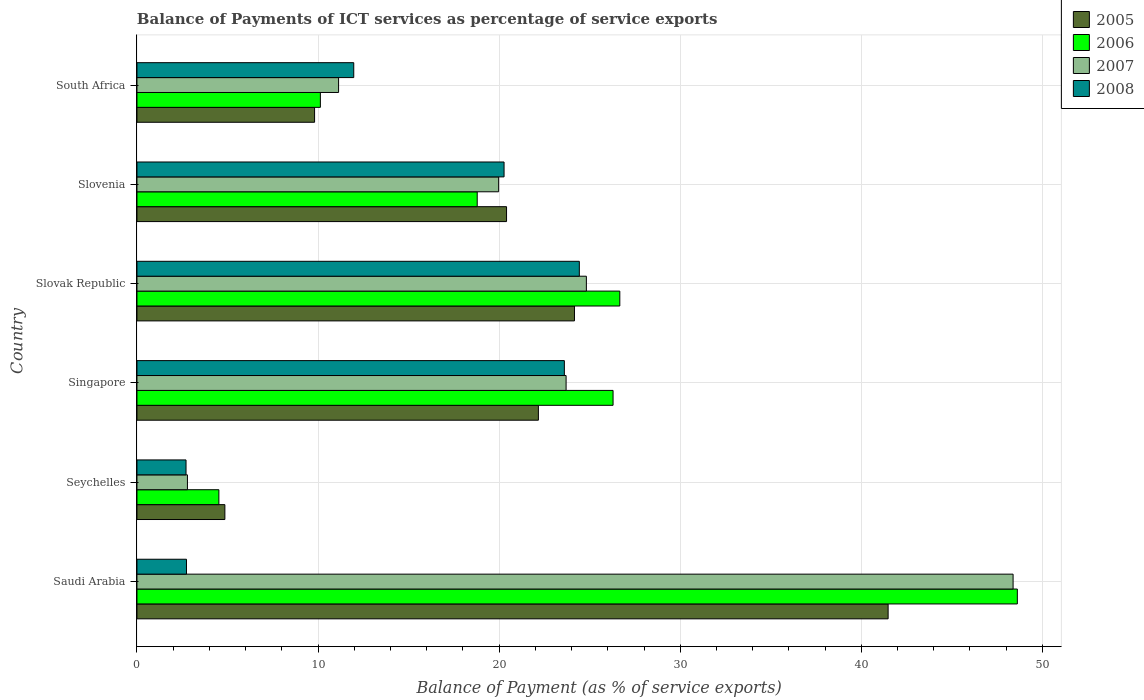How many groups of bars are there?
Give a very brief answer. 6. How many bars are there on the 3rd tick from the top?
Give a very brief answer. 4. What is the label of the 4th group of bars from the top?
Your answer should be very brief. Singapore. What is the balance of payments of ICT services in 2007 in Slovenia?
Give a very brief answer. 19.97. Across all countries, what is the maximum balance of payments of ICT services in 2008?
Keep it short and to the point. 24.43. Across all countries, what is the minimum balance of payments of ICT services in 2006?
Make the answer very short. 4.52. In which country was the balance of payments of ICT services in 2007 maximum?
Keep it short and to the point. Saudi Arabia. In which country was the balance of payments of ICT services in 2008 minimum?
Offer a terse response. Seychelles. What is the total balance of payments of ICT services in 2008 in the graph?
Provide a succinct answer. 85.72. What is the difference between the balance of payments of ICT services in 2005 in Seychelles and that in Slovenia?
Keep it short and to the point. -15.56. What is the difference between the balance of payments of ICT services in 2005 in Seychelles and the balance of payments of ICT services in 2008 in Slovenia?
Offer a very short reply. -15.42. What is the average balance of payments of ICT services in 2006 per country?
Offer a very short reply. 22.5. What is the difference between the balance of payments of ICT services in 2008 and balance of payments of ICT services in 2007 in Saudi Arabia?
Your response must be concise. -45.65. In how many countries, is the balance of payments of ICT services in 2008 greater than 34 %?
Offer a terse response. 0. What is the ratio of the balance of payments of ICT services in 2006 in Singapore to that in South Africa?
Make the answer very short. 2.6. Is the balance of payments of ICT services in 2008 in Slovenia less than that in South Africa?
Provide a succinct answer. No. Is the difference between the balance of payments of ICT services in 2008 in Seychelles and Slovak Republic greater than the difference between the balance of payments of ICT services in 2007 in Seychelles and Slovak Republic?
Offer a very short reply. Yes. What is the difference between the highest and the second highest balance of payments of ICT services in 2007?
Your response must be concise. 23.56. What is the difference between the highest and the lowest balance of payments of ICT services in 2007?
Your response must be concise. 45.59. In how many countries, is the balance of payments of ICT services in 2008 greater than the average balance of payments of ICT services in 2008 taken over all countries?
Offer a terse response. 3. Is the sum of the balance of payments of ICT services in 2005 in Seychelles and Slovak Republic greater than the maximum balance of payments of ICT services in 2006 across all countries?
Your answer should be compact. No. How many bars are there?
Give a very brief answer. 24. Are all the bars in the graph horizontal?
Give a very brief answer. Yes. How many countries are there in the graph?
Give a very brief answer. 6. Does the graph contain any zero values?
Keep it short and to the point. No. Where does the legend appear in the graph?
Make the answer very short. Top right. How many legend labels are there?
Your answer should be compact. 4. How are the legend labels stacked?
Provide a short and direct response. Vertical. What is the title of the graph?
Your response must be concise. Balance of Payments of ICT services as percentage of service exports. What is the label or title of the X-axis?
Provide a short and direct response. Balance of Payment (as % of service exports). What is the Balance of Payment (as % of service exports) in 2005 in Saudi Arabia?
Give a very brief answer. 41.48. What is the Balance of Payment (as % of service exports) of 2006 in Saudi Arabia?
Offer a very short reply. 48.62. What is the Balance of Payment (as % of service exports) in 2007 in Saudi Arabia?
Your answer should be very brief. 48.38. What is the Balance of Payment (as % of service exports) of 2008 in Saudi Arabia?
Provide a succinct answer. 2.73. What is the Balance of Payment (as % of service exports) of 2005 in Seychelles?
Keep it short and to the point. 4.85. What is the Balance of Payment (as % of service exports) in 2006 in Seychelles?
Your response must be concise. 4.52. What is the Balance of Payment (as % of service exports) of 2007 in Seychelles?
Make the answer very short. 2.79. What is the Balance of Payment (as % of service exports) in 2008 in Seychelles?
Your answer should be very brief. 2.71. What is the Balance of Payment (as % of service exports) in 2005 in Singapore?
Your answer should be compact. 22.17. What is the Balance of Payment (as % of service exports) in 2006 in Singapore?
Your answer should be very brief. 26.29. What is the Balance of Payment (as % of service exports) in 2007 in Singapore?
Provide a short and direct response. 23.7. What is the Balance of Payment (as % of service exports) in 2008 in Singapore?
Your answer should be very brief. 23.6. What is the Balance of Payment (as % of service exports) in 2005 in Slovak Republic?
Give a very brief answer. 24.16. What is the Balance of Payment (as % of service exports) in 2006 in Slovak Republic?
Your answer should be very brief. 26.66. What is the Balance of Payment (as % of service exports) in 2007 in Slovak Republic?
Ensure brevity in your answer.  24.82. What is the Balance of Payment (as % of service exports) of 2008 in Slovak Republic?
Provide a short and direct response. 24.43. What is the Balance of Payment (as % of service exports) of 2005 in Slovenia?
Offer a terse response. 20.41. What is the Balance of Payment (as % of service exports) of 2006 in Slovenia?
Ensure brevity in your answer.  18.79. What is the Balance of Payment (as % of service exports) of 2007 in Slovenia?
Make the answer very short. 19.97. What is the Balance of Payment (as % of service exports) in 2008 in Slovenia?
Offer a very short reply. 20.27. What is the Balance of Payment (as % of service exports) of 2005 in South Africa?
Provide a succinct answer. 9.81. What is the Balance of Payment (as % of service exports) of 2006 in South Africa?
Keep it short and to the point. 10.13. What is the Balance of Payment (as % of service exports) of 2007 in South Africa?
Make the answer very short. 11.13. What is the Balance of Payment (as % of service exports) of 2008 in South Africa?
Make the answer very short. 11.97. Across all countries, what is the maximum Balance of Payment (as % of service exports) of 2005?
Your answer should be very brief. 41.48. Across all countries, what is the maximum Balance of Payment (as % of service exports) of 2006?
Make the answer very short. 48.62. Across all countries, what is the maximum Balance of Payment (as % of service exports) in 2007?
Your answer should be very brief. 48.38. Across all countries, what is the maximum Balance of Payment (as % of service exports) in 2008?
Ensure brevity in your answer.  24.43. Across all countries, what is the minimum Balance of Payment (as % of service exports) of 2005?
Provide a short and direct response. 4.85. Across all countries, what is the minimum Balance of Payment (as % of service exports) of 2006?
Keep it short and to the point. 4.52. Across all countries, what is the minimum Balance of Payment (as % of service exports) of 2007?
Your response must be concise. 2.79. Across all countries, what is the minimum Balance of Payment (as % of service exports) of 2008?
Ensure brevity in your answer.  2.71. What is the total Balance of Payment (as % of service exports) in 2005 in the graph?
Provide a succinct answer. 122.88. What is the total Balance of Payment (as % of service exports) in 2006 in the graph?
Make the answer very short. 135.02. What is the total Balance of Payment (as % of service exports) in 2007 in the graph?
Provide a succinct answer. 130.79. What is the total Balance of Payment (as % of service exports) of 2008 in the graph?
Offer a terse response. 85.72. What is the difference between the Balance of Payment (as % of service exports) in 2005 in Saudi Arabia and that in Seychelles?
Your answer should be very brief. 36.63. What is the difference between the Balance of Payment (as % of service exports) in 2006 in Saudi Arabia and that in Seychelles?
Make the answer very short. 44.09. What is the difference between the Balance of Payment (as % of service exports) of 2007 in Saudi Arabia and that in Seychelles?
Ensure brevity in your answer.  45.59. What is the difference between the Balance of Payment (as % of service exports) of 2008 in Saudi Arabia and that in Seychelles?
Your answer should be very brief. 0.03. What is the difference between the Balance of Payment (as % of service exports) of 2005 in Saudi Arabia and that in Singapore?
Ensure brevity in your answer.  19.31. What is the difference between the Balance of Payment (as % of service exports) of 2006 in Saudi Arabia and that in Singapore?
Keep it short and to the point. 22.33. What is the difference between the Balance of Payment (as % of service exports) in 2007 in Saudi Arabia and that in Singapore?
Give a very brief answer. 24.68. What is the difference between the Balance of Payment (as % of service exports) in 2008 in Saudi Arabia and that in Singapore?
Offer a terse response. -20.87. What is the difference between the Balance of Payment (as % of service exports) in 2005 in Saudi Arabia and that in Slovak Republic?
Give a very brief answer. 17.32. What is the difference between the Balance of Payment (as % of service exports) of 2006 in Saudi Arabia and that in Slovak Republic?
Ensure brevity in your answer.  21.95. What is the difference between the Balance of Payment (as % of service exports) of 2007 in Saudi Arabia and that in Slovak Republic?
Offer a very short reply. 23.56. What is the difference between the Balance of Payment (as % of service exports) of 2008 in Saudi Arabia and that in Slovak Republic?
Provide a succinct answer. -21.69. What is the difference between the Balance of Payment (as % of service exports) in 2005 in Saudi Arabia and that in Slovenia?
Your answer should be very brief. 21.07. What is the difference between the Balance of Payment (as % of service exports) in 2006 in Saudi Arabia and that in Slovenia?
Make the answer very short. 29.83. What is the difference between the Balance of Payment (as % of service exports) in 2007 in Saudi Arabia and that in Slovenia?
Give a very brief answer. 28.41. What is the difference between the Balance of Payment (as % of service exports) in 2008 in Saudi Arabia and that in Slovenia?
Offer a terse response. -17.54. What is the difference between the Balance of Payment (as % of service exports) of 2005 in Saudi Arabia and that in South Africa?
Offer a terse response. 31.67. What is the difference between the Balance of Payment (as % of service exports) in 2006 in Saudi Arabia and that in South Africa?
Offer a very short reply. 38.49. What is the difference between the Balance of Payment (as % of service exports) in 2007 in Saudi Arabia and that in South Africa?
Keep it short and to the point. 37.25. What is the difference between the Balance of Payment (as % of service exports) in 2008 in Saudi Arabia and that in South Africa?
Offer a very short reply. -9.24. What is the difference between the Balance of Payment (as % of service exports) in 2005 in Seychelles and that in Singapore?
Keep it short and to the point. -17.31. What is the difference between the Balance of Payment (as % of service exports) of 2006 in Seychelles and that in Singapore?
Your response must be concise. -21.77. What is the difference between the Balance of Payment (as % of service exports) of 2007 in Seychelles and that in Singapore?
Provide a succinct answer. -20.91. What is the difference between the Balance of Payment (as % of service exports) of 2008 in Seychelles and that in Singapore?
Offer a very short reply. -20.89. What is the difference between the Balance of Payment (as % of service exports) in 2005 in Seychelles and that in Slovak Republic?
Provide a short and direct response. -19.31. What is the difference between the Balance of Payment (as % of service exports) in 2006 in Seychelles and that in Slovak Republic?
Make the answer very short. -22.14. What is the difference between the Balance of Payment (as % of service exports) in 2007 in Seychelles and that in Slovak Republic?
Your answer should be very brief. -22.03. What is the difference between the Balance of Payment (as % of service exports) in 2008 in Seychelles and that in Slovak Republic?
Provide a short and direct response. -21.72. What is the difference between the Balance of Payment (as % of service exports) in 2005 in Seychelles and that in Slovenia?
Provide a short and direct response. -15.56. What is the difference between the Balance of Payment (as % of service exports) in 2006 in Seychelles and that in Slovenia?
Make the answer very short. -14.27. What is the difference between the Balance of Payment (as % of service exports) of 2007 in Seychelles and that in Slovenia?
Provide a short and direct response. -17.19. What is the difference between the Balance of Payment (as % of service exports) in 2008 in Seychelles and that in Slovenia?
Give a very brief answer. -17.56. What is the difference between the Balance of Payment (as % of service exports) of 2005 in Seychelles and that in South Africa?
Your response must be concise. -4.95. What is the difference between the Balance of Payment (as % of service exports) of 2006 in Seychelles and that in South Africa?
Your answer should be very brief. -5.61. What is the difference between the Balance of Payment (as % of service exports) of 2007 in Seychelles and that in South Africa?
Give a very brief answer. -8.35. What is the difference between the Balance of Payment (as % of service exports) of 2008 in Seychelles and that in South Africa?
Offer a terse response. -9.26. What is the difference between the Balance of Payment (as % of service exports) of 2005 in Singapore and that in Slovak Republic?
Your answer should be compact. -1.99. What is the difference between the Balance of Payment (as % of service exports) in 2006 in Singapore and that in Slovak Republic?
Give a very brief answer. -0.37. What is the difference between the Balance of Payment (as % of service exports) in 2007 in Singapore and that in Slovak Republic?
Provide a succinct answer. -1.12. What is the difference between the Balance of Payment (as % of service exports) in 2008 in Singapore and that in Slovak Republic?
Your answer should be compact. -0.83. What is the difference between the Balance of Payment (as % of service exports) in 2005 in Singapore and that in Slovenia?
Ensure brevity in your answer.  1.76. What is the difference between the Balance of Payment (as % of service exports) in 2006 in Singapore and that in Slovenia?
Provide a short and direct response. 7.5. What is the difference between the Balance of Payment (as % of service exports) in 2007 in Singapore and that in Slovenia?
Your answer should be very brief. 3.72. What is the difference between the Balance of Payment (as % of service exports) of 2008 in Singapore and that in Slovenia?
Offer a terse response. 3.33. What is the difference between the Balance of Payment (as % of service exports) in 2005 in Singapore and that in South Africa?
Offer a very short reply. 12.36. What is the difference between the Balance of Payment (as % of service exports) in 2006 in Singapore and that in South Africa?
Give a very brief answer. 16.16. What is the difference between the Balance of Payment (as % of service exports) in 2007 in Singapore and that in South Africa?
Keep it short and to the point. 12.56. What is the difference between the Balance of Payment (as % of service exports) of 2008 in Singapore and that in South Africa?
Provide a short and direct response. 11.63. What is the difference between the Balance of Payment (as % of service exports) in 2005 in Slovak Republic and that in Slovenia?
Ensure brevity in your answer.  3.75. What is the difference between the Balance of Payment (as % of service exports) in 2006 in Slovak Republic and that in Slovenia?
Make the answer very short. 7.87. What is the difference between the Balance of Payment (as % of service exports) in 2007 in Slovak Republic and that in Slovenia?
Give a very brief answer. 4.84. What is the difference between the Balance of Payment (as % of service exports) of 2008 in Slovak Republic and that in Slovenia?
Keep it short and to the point. 4.16. What is the difference between the Balance of Payment (as % of service exports) of 2005 in Slovak Republic and that in South Africa?
Provide a succinct answer. 14.35. What is the difference between the Balance of Payment (as % of service exports) in 2006 in Slovak Republic and that in South Africa?
Keep it short and to the point. 16.54. What is the difference between the Balance of Payment (as % of service exports) of 2007 in Slovak Republic and that in South Africa?
Your response must be concise. 13.68. What is the difference between the Balance of Payment (as % of service exports) of 2008 in Slovak Republic and that in South Africa?
Your answer should be very brief. 12.46. What is the difference between the Balance of Payment (as % of service exports) in 2005 in Slovenia and that in South Africa?
Your response must be concise. 10.6. What is the difference between the Balance of Payment (as % of service exports) of 2006 in Slovenia and that in South Africa?
Make the answer very short. 8.66. What is the difference between the Balance of Payment (as % of service exports) of 2007 in Slovenia and that in South Africa?
Offer a terse response. 8.84. What is the difference between the Balance of Payment (as % of service exports) of 2008 in Slovenia and that in South Africa?
Offer a terse response. 8.3. What is the difference between the Balance of Payment (as % of service exports) in 2005 in Saudi Arabia and the Balance of Payment (as % of service exports) in 2006 in Seychelles?
Your answer should be very brief. 36.96. What is the difference between the Balance of Payment (as % of service exports) in 2005 in Saudi Arabia and the Balance of Payment (as % of service exports) in 2007 in Seychelles?
Offer a very short reply. 38.69. What is the difference between the Balance of Payment (as % of service exports) of 2005 in Saudi Arabia and the Balance of Payment (as % of service exports) of 2008 in Seychelles?
Your answer should be very brief. 38.77. What is the difference between the Balance of Payment (as % of service exports) in 2006 in Saudi Arabia and the Balance of Payment (as % of service exports) in 2007 in Seychelles?
Keep it short and to the point. 45.83. What is the difference between the Balance of Payment (as % of service exports) in 2006 in Saudi Arabia and the Balance of Payment (as % of service exports) in 2008 in Seychelles?
Offer a very short reply. 45.91. What is the difference between the Balance of Payment (as % of service exports) of 2007 in Saudi Arabia and the Balance of Payment (as % of service exports) of 2008 in Seychelles?
Your answer should be compact. 45.67. What is the difference between the Balance of Payment (as % of service exports) in 2005 in Saudi Arabia and the Balance of Payment (as % of service exports) in 2006 in Singapore?
Your response must be concise. 15.19. What is the difference between the Balance of Payment (as % of service exports) of 2005 in Saudi Arabia and the Balance of Payment (as % of service exports) of 2007 in Singapore?
Make the answer very short. 17.78. What is the difference between the Balance of Payment (as % of service exports) of 2005 in Saudi Arabia and the Balance of Payment (as % of service exports) of 2008 in Singapore?
Make the answer very short. 17.88. What is the difference between the Balance of Payment (as % of service exports) in 2006 in Saudi Arabia and the Balance of Payment (as % of service exports) in 2007 in Singapore?
Keep it short and to the point. 24.92. What is the difference between the Balance of Payment (as % of service exports) in 2006 in Saudi Arabia and the Balance of Payment (as % of service exports) in 2008 in Singapore?
Provide a succinct answer. 25.02. What is the difference between the Balance of Payment (as % of service exports) of 2007 in Saudi Arabia and the Balance of Payment (as % of service exports) of 2008 in Singapore?
Make the answer very short. 24.78. What is the difference between the Balance of Payment (as % of service exports) in 2005 in Saudi Arabia and the Balance of Payment (as % of service exports) in 2006 in Slovak Republic?
Make the answer very short. 14.82. What is the difference between the Balance of Payment (as % of service exports) in 2005 in Saudi Arabia and the Balance of Payment (as % of service exports) in 2007 in Slovak Republic?
Offer a terse response. 16.66. What is the difference between the Balance of Payment (as % of service exports) of 2005 in Saudi Arabia and the Balance of Payment (as % of service exports) of 2008 in Slovak Republic?
Ensure brevity in your answer.  17.05. What is the difference between the Balance of Payment (as % of service exports) in 2006 in Saudi Arabia and the Balance of Payment (as % of service exports) in 2007 in Slovak Republic?
Make the answer very short. 23.8. What is the difference between the Balance of Payment (as % of service exports) in 2006 in Saudi Arabia and the Balance of Payment (as % of service exports) in 2008 in Slovak Republic?
Give a very brief answer. 24.19. What is the difference between the Balance of Payment (as % of service exports) in 2007 in Saudi Arabia and the Balance of Payment (as % of service exports) in 2008 in Slovak Republic?
Give a very brief answer. 23.95. What is the difference between the Balance of Payment (as % of service exports) of 2005 in Saudi Arabia and the Balance of Payment (as % of service exports) of 2006 in Slovenia?
Provide a succinct answer. 22.69. What is the difference between the Balance of Payment (as % of service exports) of 2005 in Saudi Arabia and the Balance of Payment (as % of service exports) of 2007 in Slovenia?
Ensure brevity in your answer.  21.51. What is the difference between the Balance of Payment (as % of service exports) in 2005 in Saudi Arabia and the Balance of Payment (as % of service exports) in 2008 in Slovenia?
Offer a terse response. 21.21. What is the difference between the Balance of Payment (as % of service exports) in 2006 in Saudi Arabia and the Balance of Payment (as % of service exports) in 2007 in Slovenia?
Offer a very short reply. 28.64. What is the difference between the Balance of Payment (as % of service exports) of 2006 in Saudi Arabia and the Balance of Payment (as % of service exports) of 2008 in Slovenia?
Provide a succinct answer. 28.35. What is the difference between the Balance of Payment (as % of service exports) of 2007 in Saudi Arabia and the Balance of Payment (as % of service exports) of 2008 in Slovenia?
Give a very brief answer. 28.11. What is the difference between the Balance of Payment (as % of service exports) of 2005 in Saudi Arabia and the Balance of Payment (as % of service exports) of 2006 in South Africa?
Provide a short and direct response. 31.35. What is the difference between the Balance of Payment (as % of service exports) of 2005 in Saudi Arabia and the Balance of Payment (as % of service exports) of 2007 in South Africa?
Make the answer very short. 30.35. What is the difference between the Balance of Payment (as % of service exports) in 2005 in Saudi Arabia and the Balance of Payment (as % of service exports) in 2008 in South Africa?
Ensure brevity in your answer.  29.51. What is the difference between the Balance of Payment (as % of service exports) in 2006 in Saudi Arabia and the Balance of Payment (as % of service exports) in 2007 in South Africa?
Your response must be concise. 37.48. What is the difference between the Balance of Payment (as % of service exports) of 2006 in Saudi Arabia and the Balance of Payment (as % of service exports) of 2008 in South Africa?
Make the answer very short. 36.65. What is the difference between the Balance of Payment (as % of service exports) in 2007 in Saudi Arabia and the Balance of Payment (as % of service exports) in 2008 in South Africa?
Offer a very short reply. 36.41. What is the difference between the Balance of Payment (as % of service exports) in 2005 in Seychelles and the Balance of Payment (as % of service exports) in 2006 in Singapore?
Provide a succinct answer. -21.44. What is the difference between the Balance of Payment (as % of service exports) of 2005 in Seychelles and the Balance of Payment (as % of service exports) of 2007 in Singapore?
Make the answer very short. -18.84. What is the difference between the Balance of Payment (as % of service exports) in 2005 in Seychelles and the Balance of Payment (as % of service exports) in 2008 in Singapore?
Offer a very short reply. -18.75. What is the difference between the Balance of Payment (as % of service exports) of 2006 in Seychelles and the Balance of Payment (as % of service exports) of 2007 in Singapore?
Make the answer very short. -19.18. What is the difference between the Balance of Payment (as % of service exports) of 2006 in Seychelles and the Balance of Payment (as % of service exports) of 2008 in Singapore?
Your response must be concise. -19.08. What is the difference between the Balance of Payment (as % of service exports) of 2007 in Seychelles and the Balance of Payment (as % of service exports) of 2008 in Singapore?
Keep it short and to the point. -20.81. What is the difference between the Balance of Payment (as % of service exports) in 2005 in Seychelles and the Balance of Payment (as % of service exports) in 2006 in Slovak Republic?
Make the answer very short. -21.81. What is the difference between the Balance of Payment (as % of service exports) of 2005 in Seychelles and the Balance of Payment (as % of service exports) of 2007 in Slovak Republic?
Provide a succinct answer. -19.96. What is the difference between the Balance of Payment (as % of service exports) of 2005 in Seychelles and the Balance of Payment (as % of service exports) of 2008 in Slovak Republic?
Provide a short and direct response. -19.57. What is the difference between the Balance of Payment (as % of service exports) in 2006 in Seychelles and the Balance of Payment (as % of service exports) in 2007 in Slovak Republic?
Provide a short and direct response. -20.3. What is the difference between the Balance of Payment (as % of service exports) in 2006 in Seychelles and the Balance of Payment (as % of service exports) in 2008 in Slovak Republic?
Offer a terse response. -19.91. What is the difference between the Balance of Payment (as % of service exports) in 2007 in Seychelles and the Balance of Payment (as % of service exports) in 2008 in Slovak Republic?
Offer a very short reply. -21.64. What is the difference between the Balance of Payment (as % of service exports) in 2005 in Seychelles and the Balance of Payment (as % of service exports) in 2006 in Slovenia?
Provide a short and direct response. -13.94. What is the difference between the Balance of Payment (as % of service exports) in 2005 in Seychelles and the Balance of Payment (as % of service exports) in 2007 in Slovenia?
Offer a very short reply. -15.12. What is the difference between the Balance of Payment (as % of service exports) of 2005 in Seychelles and the Balance of Payment (as % of service exports) of 2008 in Slovenia?
Offer a terse response. -15.42. What is the difference between the Balance of Payment (as % of service exports) of 2006 in Seychelles and the Balance of Payment (as % of service exports) of 2007 in Slovenia?
Keep it short and to the point. -15.45. What is the difference between the Balance of Payment (as % of service exports) of 2006 in Seychelles and the Balance of Payment (as % of service exports) of 2008 in Slovenia?
Keep it short and to the point. -15.75. What is the difference between the Balance of Payment (as % of service exports) of 2007 in Seychelles and the Balance of Payment (as % of service exports) of 2008 in Slovenia?
Keep it short and to the point. -17.48. What is the difference between the Balance of Payment (as % of service exports) of 2005 in Seychelles and the Balance of Payment (as % of service exports) of 2006 in South Africa?
Make the answer very short. -5.27. What is the difference between the Balance of Payment (as % of service exports) in 2005 in Seychelles and the Balance of Payment (as % of service exports) in 2007 in South Africa?
Provide a short and direct response. -6.28. What is the difference between the Balance of Payment (as % of service exports) in 2005 in Seychelles and the Balance of Payment (as % of service exports) in 2008 in South Africa?
Make the answer very short. -7.12. What is the difference between the Balance of Payment (as % of service exports) of 2006 in Seychelles and the Balance of Payment (as % of service exports) of 2007 in South Africa?
Keep it short and to the point. -6.61. What is the difference between the Balance of Payment (as % of service exports) in 2006 in Seychelles and the Balance of Payment (as % of service exports) in 2008 in South Africa?
Provide a short and direct response. -7.45. What is the difference between the Balance of Payment (as % of service exports) of 2007 in Seychelles and the Balance of Payment (as % of service exports) of 2008 in South Africa?
Your answer should be compact. -9.18. What is the difference between the Balance of Payment (as % of service exports) of 2005 in Singapore and the Balance of Payment (as % of service exports) of 2006 in Slovak Republic?
Offer a terse response. -4.5. What is the difference between the Balance of Payment (as % of service exports) of 2005 in Singapore and the Balance of Payment (as % of service exports) of 2007 in Slovak Republic?
Provide a short and direct response. -2.65. What is the difference between the Balance of Payment (as % of service exports) in 2005 in Singapore and the Balance of Payment (as % of service exports) in 2008 in Slovak Republic?
Offer a very short reply. -2.26. What is the difference between the Balance of Payment (as % of service exports) of 2006 in Singapore and the Balance of Payment (as % of service exports) of 2007 in Slovak Republic?
Ensure brevity in your answer.  1.47. What is the difference between the Balance of Payment (as % of service exports) of 2006 in Singapore and the Balance of Payment (as % of service exports) of 2008 in Slovak Republic?
Provide a succinct answer. 1.86. What is the difference between the Balance of Payment (as % of service exports) of 2007 in Singapore and the Balance of Payment (as % of service exports) of 2008 in Slovak Republic?
Your answer should be compact. -0.73. What is the difference between the Balance of Payment (as % of service exports) in 2005 in Singapore and the Balance of Payment (as % of service exports) in 2006 in Slovenia?
Your answer should be very brief. 3.38. What is the difference between the Balance of Payment (as % of service exports) in 2005 in Singapore and the Balance of Payment (as % of service exports) in 2007 in Slovenia?
Keep it short and to the point. 2.19. What is the difference between the Balance of Payment (as % of service exports) of 2005 in Singapore and the Balance of Payment (as % of service exports) of 2008 in Slovenia?
Provide a succinct answer. 1.9. What is the difference between the Balance of Payment (as % of service exports) in 2006 in Singapore and the Balance of Payment (as % of service exports) in 2007 in Slovenia?
Provide a succinct answer. 6.32. What is the difference between the Balance of Payment (as % of service exports) of 2006 in Singapore and the Balance of Payment (as % of service exports) of 2008 in Slovenia?
Ensure brevity in your answer.  6.02. What is the difference between the Balance of Payment (as % of service exports) of 2007 in Singapore and the Balance of Payment (as % of service exports) of 2008 in Slovenia?
Your answer should be very brief. 3.43. What is the difference between the Balance of Payment (as % of service exports) of 2005 in Singapore and the Balance of Payment (as % of service exports) of 2006 in South Africa?
Your response must be concise. 12.04. What is the difference between the Balance of Payment (as % of service exports) of 2005 in Singapore and the Balance of Payment (as % of service exports) of 2007 in South Africa?
Give a very brief answer. 11.03. What is the difference between the Balance of Payment (as % of service exports) of 2005 in Singapore and the Balance of Payment (as % of service exports) of 2008 in South Africa?
Offer a very short reply. 10.2. What is the difference between the Balance of Payment (as % of service exports) of 2006 in Singapore and the Balance of Payment (as % of service exports) of 2007 in South Africa?
Offer a very short reply. 15.16. What is the difference between the Balance of Payment (as % of service exports) in 2006 in Singapore and the Balance of Payment (as % of service exports) in 2008 in South Africa?
Your answer should be very brief. 14.32. What is the difference between the Balance of Payment (as % of service exports) in 2007 in Singapore and the Balance of Payment (as % of service exports) in 2008 in South Africa?
Your answer should be very brief. 11.73. What is the difference between the Balance of Payment (as % of service exports) of 2005 in Slovak Republic and the Balance of Payment (as % of service exports) of 2006 in Slovenia?
Your response must be concise. 5.37. What is the difference between the Balance of Payment (as % of service exports) of 2005 in Slovak Republic and the Balance of Payment (as % of service exports) of 2007 in Slovenia?
Keep it short and to the point. 4.19. What is the difference between the Balance of Payment (as % of service exports) of 2005 in Slovak Republic and the Balance of Payment (as % of service exports) of 2008 in Slovenia?
Keep it short and to the point. 3.89. What is the difference between the Balance of Payment (as % of service exports) of 2006 in Slovak Republic and the Balance of Payment (as % of service exports) of 2007 in Slovenia?
Give a very brief answer. 6.69. What is the difference between the Balance of Payment (as % of service exports) in 2006 in Slovak Republic and the Balance of Payment (as % of service exports) in 2008 in Slovenia?
Ensure brevity in your answer.  6.39. What is the difference between the Balance of Payment (as % of service exports) of 2007 in Slovak Republic and the Balance of Payment (as % of service exports) of 2008 in Slovenia?
Your answer should be compact. 4.55. What is the difference between the Balance of Payment (as % of service exports) in 2005 in Slovak Republic and the Balance of Payment (as % of service exports) in 2006 in South Africa?
Your response must be concise. 14.03. What is the difference between the Balance of Payment (as % of service exports) in 2005 in Slovak Republic and the Balance of Payment (as % of service exports) in 2007 in South Africa?
Keep it short and to the point. 13.03. What is the difference between the Balance of Payment (as % of service exports) of 2005 in Slovak Republic and the Balance of Payment (as % of service exports) of 2008 in South Africa?
Offer a terse response. 12.19. What is the difference between the Balance of Payment (as % of service exports) of 2006 in Slovak Republic and the Balance of Payment (as % of service exports) of 2007 in South Africa?
Ensure brevity in your answer.  15.53. What is the difference between the Balance of Payment (as % of service exports) in 2006 in Slovak Republic and the Balance of Payment (as % of service exports) in 2008 in South Africa?
Your answer should be compact. 14.69. What is the difference between the Balance of Payment (as % of service exports) in 2007 in Slovak Republic and the Balance of Payment (as % of service exports) in 2008 in South Africa?
Your answer should be very brief. 12.85. What is the difference between the Balance of Payment (as % of service exports) in 2005 in Slovenia and the Balance of Payment (as % of service exports) in 2006 in South Africa?
Your answer should be very brief. 10.28. What is the difference between the Balance of Payment (as % of service exports) in 2005 in Slovenia and the Balance of Payment (as % of service exports) in 2007 in South Africa?
Provide a succinct answer. 9.28. What is the difference between the Balance of Payment (as % of service exports) in 2005 in Slovenia and the Balance of Payment (as % of service exports) in 2008 in South Africa?
Offer a very short reply. 8.44. What is the difference between the Balance of Payment (as % of service exports) of 2006 in Slovenia and the Balance of Payment (as % of service exports) of 2007 in South Africa?
Provide a succinct answer. 7.66. What is the difference between the Balance of Payment (as % of service exports) in 2006 in Slovenia and the Balance of Payment (as % of service exports) in 2008 in South Africa?
Your answer should be very brief. 6.82. What is the difference between the Balance of Payment (as % of service exports) of 2007 in Slovenia and the Balance of Payment (as % of service exports) of 2008 in South Africa?
Ensure brevity in your answer.  8. What is the average Balance of Payment (as % of service exports) in 2005 per country?
Make the answer very short. 20.48. What is the average Balance of Payment (as % of service exports) in 2006 per country?
Your answer should be compact. 22.5. What is the average Balance of Payment (as % of service exports) in 2007 per country?
Your answer should be very brief. 21.8. What is the average Balance of Payment (as % of service exports) of 2008 per country?
Ensure brevity in your answer.  14.29. What is the difference between the Balance of Payment (as % of service exports) of 2005 and Balance of Payment (as % of service exports) of 2006 in Saudi Arabia?
Your response must be concise. -7.14. What is the difference between the Balance of Payment (as % of service exports) in 2005 and Balance of Payment (as % of service exports) in 2007 in Saudi Arabia?
Give a very brief answer. -6.9. What is the difference between the Balance of Payment (as % of service exports) in 2005 and Balance of Payment (as % of service exports) in 2008 in Saudi Arabia?
Provide a short and direct response. 38.75. What is the difference between the Balance of Payment (as % of service exports) of 2006 and Balance of Payment (as % of service exports) of 2007 in Saudi Arabia?
Make the answer very short. 0.24. What is the difference between the Balance of Payment (as % of service exports) in 2006 and Balance of Payment (as % of service exports) in 2008 in Saudi Arabia?
Provide a short and direct response. 45.88. What is the difference between the Balance of Payment (as % of service exports) in 2007 and Balance of Payment (as % of service exports) in 2008 in Saudi Arabia?
Offer a very short reply. 45.65. What is the difference between the Balance of Payment (as % of service exports) in 2005 and Balance of Payment (as % of service exports) in 2006 in Seychelles?
Provide a succinct answer. 0.33. What is the difference between the Balance of Payment (as % of service exports) of 2005 and Balance of Payment (as % of service exports) of 2007 in Seychelles?
Provide a short and direct response. 2.07. What is the difference between the Balance of Payment (as % of service exports) in 2005 and Balance of Payment (as % of service exports) in 2008 in Seychelles?
Your answer should be very brief. 2.14. What is the difference between the Balance of Payment (as % of service exports) of 2006 and Balance of Payment (as % of service exports) of 2007 in Seychelles?
Offer a very short reply. 1.74. What is the difference between the Balance of Payment (as % of service exports) of 2006 and Balance of Payment (as % of service exports) of 2008 in Seychelles?
Keep it short and to the point. 1.81. What is the difference between the Balance of Payment (as % of service exports) of 2007 and Balance of Payment (as % of service exports) of 2008 in Seychelles?
Keep it short and to the point. 0.08. What is the difference between the Balance of Payment (as % of service exports) of 2005 and Balance of Payment (as % of service exports) of 2006 in Singapore?
Provide a succinct answer. -4.12. What is the difference between the Balance of Payment (as % of service exports) of 2005 and Balance of Payment (as % of service exports) of 2007 in Singapore?
Offer a terse response. -1.53. What is the difference between the Balance of Payment (as % of service exports) in 2005 and Balance of Payment (as % of service exports) in 2008 in Singapore?
Make the answer very short. -1.43. What is the difference between the Balance of Payment (as % of service exports) in 2006 and Balance of Payment (as % of service exports) in 2007 in Singapore?
Keep it short and to the point. 2.59. What is the difference between the Balance of Payment (as % of service exports) in 2006 and Balance of Payment (as % of service exports) in 2008 in Singapore?
Provide a succinct answer. 2.69. What is the difference between the Balance of Payment (as % of service exports) of 2007 and Balance of Payment (as % of service exports) of 2008 in Singapore?
Provide a short and direct response. 0.1. What is the difference between the Balance of Payment (as % of service exports) of 2005 and Balance of Payment (as % of service exports) of 2006 in Slovak Republic?
Your answer should be compact. -2.5. What is the difference between the Balance of Payment (as % of service exports) of 2005 and Balance of Payment (as % of service exports) of 2007 in Slovak Republic?
Offer a very short reply. -0.66. What is the difference between the Balance of Payment (as % of service exports) of 2005 and Balance of Payment (as % of service exports) of 2008 in Slovak Republic?
Your response must be concise. -0.27. What is the difference between the Balance of Payment (as % of service exports) of 2006 and Balance of Payment (as % of service exports) of 2007 in Slovak Republic?
Provide a succinct answer. 1.85. What is the difference between the Balance of Payment (as % of service exports) of 2006 and Balance of Payment (as % of service exports) of 2008 in Slovak Republic?
Provide a succinct answer. 2.24. What is the difference between the Balance of Payment (as % of service exports) in 2007 and Balance of Payment (as % of service exports) in 2008 in Slovak Republic?
Make the answer very short. 0.39. What is the difference between the Balance of Payment (as % of service exports) of 2005 and Balance of Payment (as % of service exports) of 2006 in Slovenia?
Give a very brief answer. 1.62. What is the difference between the Balance of Payment (as % of service exports) of 2005 and Balance of Payment (as % of service exports) of 2007 in Slovenia?
Your answer should be compact. 0.44. What is the difference between the Balance of Payment (as % of service exports) of 2005 and Balance of Payment (as % of service exports) of 2008 in Slovenia?
Your response must be concise. 0.14. What is the difference between the Balance of Payment (as % of service exports) in 2006 and Balance of Payment (as % of service exports) in 2007 in Slovenia?
Keep it short and to the point. -1.18. What is the difference between the Balance of Payment (as % of service exports) in 2006 and Balance of Payment (as % of service exports) in 2008 in Slovenia?
Offer a very short reply. -1.48. What is the difference between the Balance of Payment (as % of service exports) in 2007 and Balance of Payment (as % of service exports) in 2008 in Slovenia?
Offer a very short reply. -0.3. What is the difference between the Balance of Payment (as % of service exports) of 2005 and Balance of Payment (as % of service exports) of 2006 in South Africa?
Ensure brevity in your answer.  -0.32. What is the difference between the Balance of Payment (as % of service exports) in 2005 and Balance of Payment (as % of service exports) in 2007 in South Africa?
Your response must be concise. -1.33. What is the difference between the Balance of Payment (as % of service exports) of 2005 and Balance of Payment (as % of service exports) of 2008 in South Africa?
Your answer should be compact. -2.16. What is the difference between the Balance of Payment (as % of service exports) of 2006 and Balance of Payment (as % of service exports) of 2007 in South Africa?
Your answer should be very brief. -1. What is the difference between the Balance of Payment (as % of service exports) in 2006 and Balance of Payment (as % of service exports) in 2008 in South Africa?
Your response must be concise. -1.84. What is the difference between the Balance of Payment (as % of service exports) of 2007 and Balance of Payment (as % of service exports) of 2008 in South Africa?
Provide a succinct answer. -0.84. What is the ratio of the Balance of Payment (as % of service exports) of 2005 in Saudi Arabia to that in Seychelles?
Your response must be concise. 8.54. What is the ratio of the Balance of Payment (as % of service exports) of 2006 in Saudi Arabia to that in Seychelles?
Keep it short and to the point. 10.75. What is the ratio of the Balance of Payment (as % of service exports) of 2007 in Saudi Arabia to that in Seychelles?
Your answer should be very brief. 17.36. What is the ratio of the Balance of Payment (as % of service exports) of 2008 in Saudi Arabia to that in Seychelles?
Give a very brief answer. 1.01. What is the ratio of the Balance of Payment (as % of service exports) of 2005 in Saudi Arabia to that in Singapore?
Give a very brief answer. 1.87. What is the ratio of the Balance of Payment (as % of service exports) of 2006 in Saudi Arabia to that in Singapore?
Provide a succinct answer. 1.85. What is the ratio of the Balance of Payment (as % of service exports) in 2007 in Saudi Arabia to that in Singapore?
Your response must be concise. 2.04. What is the ratio of the Balance of Payment (as % of service exports) in 2008 in Saudi Arabia to that in Singapore?
Offer a very short reply. 0.12. What is the ratio of the Balance of Payment (as % of service exports) of 2005 in Saudi Arabia to that in Slovak Republic?
Your answer should be very brief. 1.72. What is the ratio of the Balance of Payment (as % of service exports) in 2006 in Saudi Arabia to that in Slovak Republic?
Make the answer very short. 1.82. What is the ratio of the Balance of Payment (as % of service exports) of 2007 in Saudi Arabia to that in Slovak Republic?
Give a very brief answer. 1.95. What is the ratio of the Balance of Payment (as % of service exports) in 2008 in Saudi Arabia to that in Slovak Republic?
Offer a terse response. 0.11. What is the ratio of the Balance of Payment (as % of service exports) of 2005 in Saudi Arabia to that in Slovenia?
Provide a succinct answer. 2.03. What is the ratio of the Balance of Payment (as % of service exports) of 2006 in Saudi Arabia to that in Slovenia?
Give a very brief answer. 2.59. What is the ratio of the Balance of Payment (as % of service exports) of 2007 in Saudi Arabia to that in Slovenia?
Give a very brief answer. 2.42. What is the ratio of the Balance of Payment (as % of service exports) in 2008 in Saudi Arabia to that in Slovenia?
Provide a short and direct response. 0.13. What is the ratio of the Balance of Payment (as % of service exports) in 2005 in Saudi Arabia to that in South Africa?
Make the answer very short. 4.23. What is the ratio of the Balance of Payment (as % of service exports) of 2006 in Saudi Arabia to that in South Africa?
Give a very brief answer. 4.8. What is the ratio of the Balance of Payment (as % of service exports) of 2007 in Saudi Arabia to that in South Africa?
Your answer should be compact. 4.35. What is the ratio of the Balance of Payment (as % of service exports) of 2008 in Saudi Arabia to that in South Africa?
Make the answer very short. 0.23. What is the ratio of the Balance of Payment (as % of service exports) in 2005 in Seychelles to that in Singapore?
Ensure brevity in your answer.  0.22. What is the ratio of the Balance of Payment (as % of service exports) in 2006 in Seychelles to that in Singapore?
Ensure brevity in your answer.  0.17. What is the ratio of the Balance of Payment (as % of service exports) of 2007 in Seychelles to that in Singapore?
Provide a succinct answer. 0.12. What is the ratio of the Balance of Payment (as % of service exports) of 2008 in Seychelles to that in Singapore?
Offer a very short reply. 0.11. What is the ratio of the Balance of Payment (as % of service exports) in 2005 in Seychelles to that in Slovak Republic?
Your response must be concise. 0.2. What is the ratio of the Balance of Payment (as % of service exports) in 2006 in Seychelles to that in Slovak Republic?
Keep it short and to the point. 0.17. What is the ratio of the Balance of Payment (as % of service exports) in 2007 in Seychelles to that in Slovak Republic?
Your response must be concise. 0.11. What is the ratio of the Balance of Payment (as % of service exports) of 2008 in Seychelles to that in Slovak Republic?
Your answer should be very brief. 0.11. What is the ratio of the Balance of Payment (as % of service exports) in 2005 in Seychelles to that in Slovenia?
Keep it short and to the point. 0.24. What is the ratio of the Balance of Payment (as % of service exports) in 2006 in Seychelles to that in Slovenia?
Offer a terse response. 0.24. What is the ratio of the Balance of Payment (as % of service exports) in 2007 in Seychelles to that in Slovenia?
Your response must be concise. 0.14. What is the ratio of the Balance of Payment (as % of service exports) in 2008 in Seychelles to that in Slovenia?
Your answer should be very brief. 0.13. What is the ratio of the Balance of Payment (as % of service exports) of 2005 in Seychelles to that in South Africa?
Provide a short and direct response. 0.49. What is the ratio of the Balance of Payment (as % of service exports) in 2006 in Seychelles to that in South Africa?
Keep it short and to the point. 0.45. What is the ratio of the Balance of Payment (as % of service exports) of 2007 in Seychelles to that in South Africa?
Ensure brevity in your answer.  0.25. What is the ratio of the Balance of Payment (as % of service exports) in 2008 in Seychelles to that in South Africa?
Provide a short and direct response. 0.23. What is the ratio of the Balance of Payment (as % of service exports) in 2005 in Singapore to that in Slovak Republic?
Keep it short and to the point. 0.92. What is the ratio of the Balance of Payment (as % of service exports) in 2006 in Singapore to that in Slovak Republic?
Make the answer very short. 0.99. What is the ratio of the Balance of Payment (as % of service exports) of 2007 in Singapore to that in Slovak Republic?
Offer a very short reply. 0.95. What is the ratio of the Balance of Payment (as % of service exports) in 2008 in Singapore to that in Slovak Republic?
Your answer should be very brief. 0.97. What is the ratio of the Balance of Payment (as % of service exports) of 2005 in Singapore to that in Slovenia?
Offer a very short reply. 1.09. What is the ratio of the Balance of Payment (as % of service exports) of 2006 in Singapore to that in Slovenia?
Your answer should be very brief. 1.4. What is the ratio of the Balance of Payment (as % of service exports) of 2007 in Singapore to that in Slovenia?
Give a very brief answer. 1.19. What is the ratio of the Balance of Payment (as % of service exports) of 2008 in Singapore to that in Slovenia?
Keep it short and to the point. 1.16. What is the ratio of the Balance of Payment (as % of service exports) in 2005 in Singapore to that in South Africa?
Provide a short and direct response. 2.26. What is the ratio of the Balance of Payment (as % of service exports) of 2006 in Singapore to that in South Africa?
Your answer should be very brief. 2.6. What is the ratio of the Balance of Payment (as % of service exports) in 2007 in Singapore to that in South Africa?
Ensure brevity in your answer.  2.13. What is the ratio of the Balance of Payment (as % of service exports) of 2008 in Singapore to that in South Africa?
Give a very brief answer. 1.97. What is the ratio of the Balance of Payment (as % of service exports) in 2005 in Slovak Republic to that in Slovenia?
Give a very brief answer. 1.18. What is the ratio of the Balance of Payment (as % of service exports) of 2006 in Slovak Republic to that in Slovenia?
Offer a very short reply. 1.42. What is the ratio of the Balance of Payment (as % of service exports) of 2007 in Slovak Republic to that in Slovenia?
Your response must be concise. 1.24. What is the ratio of the Balance of Payment (as % of service exports) in 2008 in Slovak Republic to that in Slovenia?
Your answer should be compact. 1.21. What is the ratio of the Balance of Payment (as % of service exports) of 2005 in Slovak Republic to that in South Africa?
Your answer should be compact. 2.46. What is the ratio of the Balance of Payment (as % of service exports) of 2006 in Slovak Republic to that in South Africa?
Give a very brief answer. 2.63. What is the ratio of the Balance of Payment (as % of service exports) in 2007 in Slovak Republic to that in South Africa?
Provide a short and direct response. 2.23. What is the ratio of the Balance of Payment (as % of service exports) in 2008 in Slovak Republic to that in South Africa?
Give a very brief answer. 2.04. What is the ratio of the Balance of Payment (as % of service exports) in 2005 in Slovenia to that in South Africa?
Provide a succinct answer. 2.08. What is the ratio of the Balance of Payment (as % of service exports) of 2006 in Slovenia to that in South Africa?
Make the answer very short. 1.86. What is the ratio of the Balance of Payment (as % of service exports) of 2007 in Slovenia to that in South Africa?
Provide a short and direct response. 1.79. What is the ratio of the Balance of Payment (as % of service exports) of 2008 in Slovenia to that in South Africa?
Provide a succinct answer. 1.69. What is the difference between the highest and the second highest Balance of Payment (as % of service exports) of 2005?
Keep it short and to the point. 17.32. What is the difference between the highest and the second highest Balance of Payment (as % of service exports) of 2006?
Give a very brief answer. 21.95. What is the difference between the highest and the second highest Balance of Payment (as % of service exports) of 2007?
Your answer should be very brief. 23.56. What is the difference between the highest and the second highest Balance of Payment (as % of service exports) in 2008?
Keep it short and to the point. 0.83. What is the difference between the highest and the lowest Balance of Payment (as % of service exports) of 2005?
Your answer should be very brief. 36.63. What is the difference between the highest and the lowest Balance of Payment (as % of service exports) in 2006?
Give a very brief answer. 44.09. What is the difference between the highest and the lowest Balance of Payment (as % of service exports) of 2007?
Ensure brevity in your answer.  45.59. What is the difference between the highest and the lowest Balance of Payment (as % of service exports) in 2008?
Your response must be concise. 21.72. 